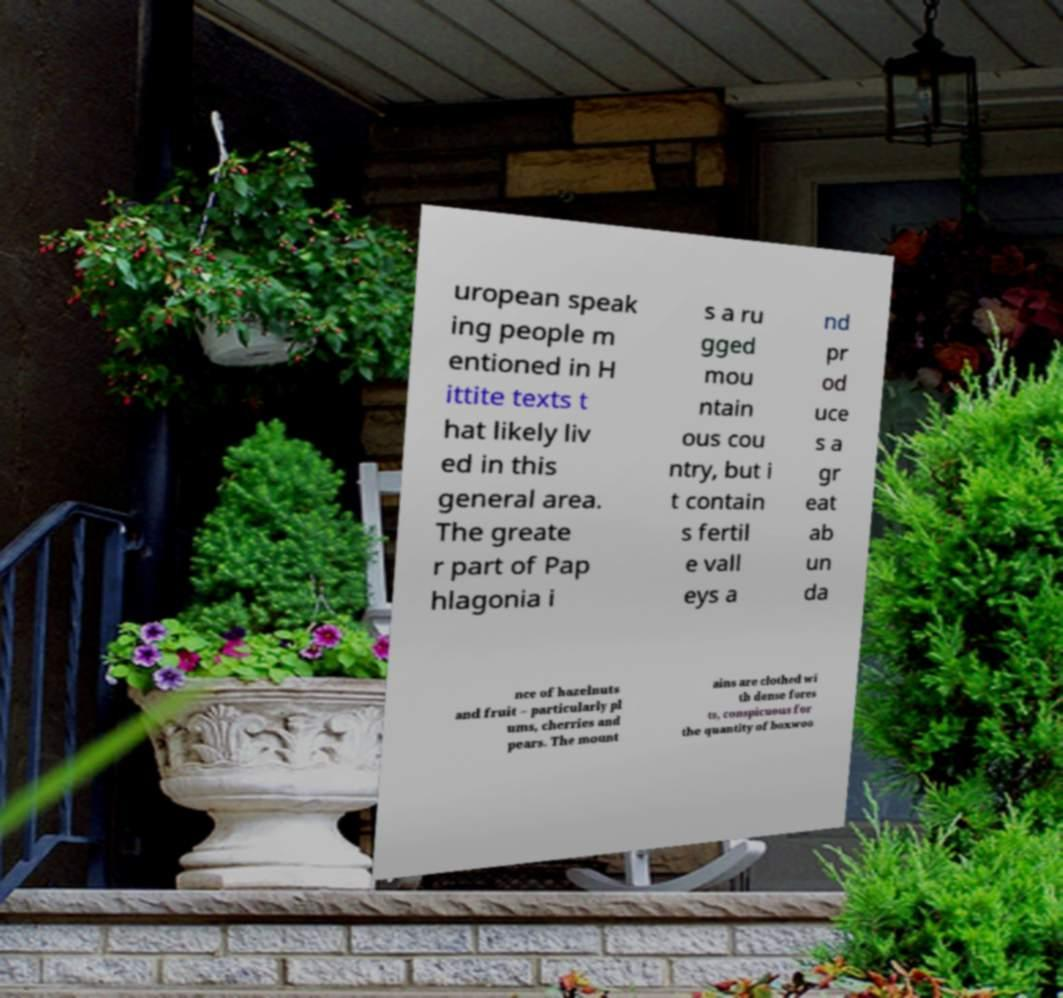Please read and relay the text visible in this image. What does it say? uropean speak ing people m entioned in H ittite texts t hat likely liv ed in this general area. The greate r part of Pap hlagonia i s a ru gged mou ntain ous cou ntry, but i t contain s fertil e vall eys a nd pr od uce s a gr eat ab un da nce of hazelnuts and fruit – particularly pl ums, cherries and pears. The mount ains are clothed wi th dense fores ts, conspicuous for the quantity of boxwoo 